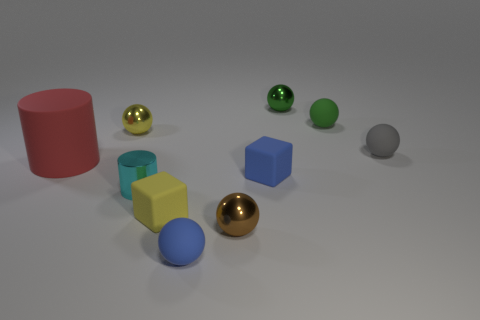Subtract all blue matte spheres. How many spheres are left? 5 Subtract all cyan cylinders. How many cylinders are left? 1 Subtract 1 blocks. How many blocks are left? 1 Subtract all spheres. How many objects are left? 4 Subtract all brown blocks. Subtract all yellow cylinders. How many blocks are left? 2 Subtract all green spheres. How many brown cylinders are left? 0 Subtract all cubes. Subtract all big green blocks. How many objects are left? 8 Add 6 shiny things. How many shiny things are left? 10 Add 7 gray rubber objects. How many gray rubber objects exist? 8 Subtract 0 purple cylinders. How many objects are left? 10 